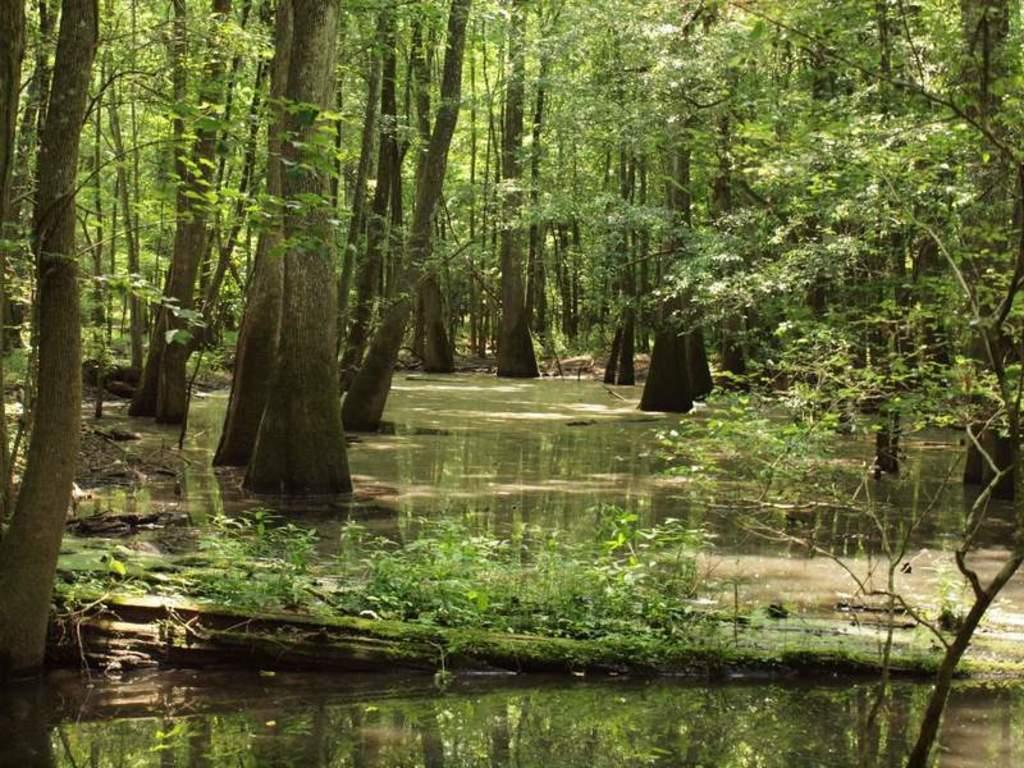Please provide a concise description of this image. This picture shows bunch of trees and we see water and few plants. 